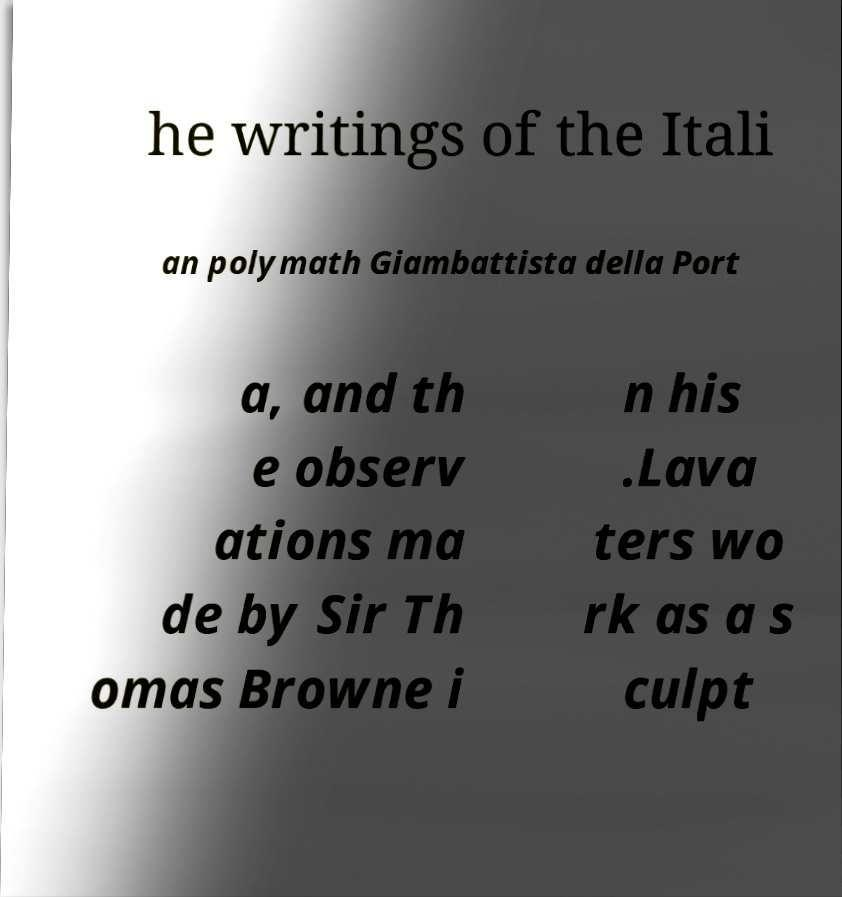Please read and relay the text visible in this image. What does it say? he writings of the Itali an polymath Giambattista della Port a, and th e observ ations ma de by Sir Th omas Browne i n his .Lava ters wo rk as a s culpt 